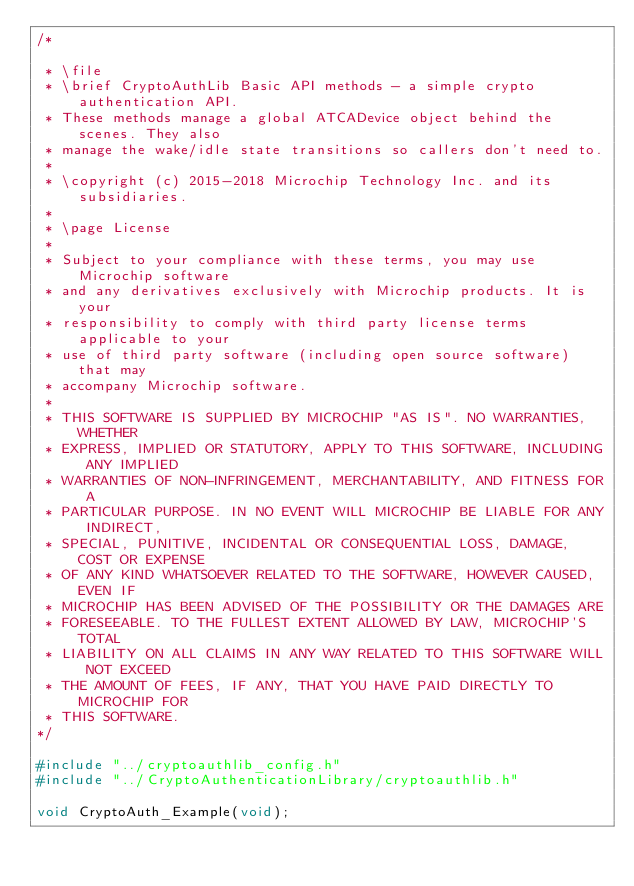<code> <loc_0><loc_0><loc_500><loc_500><_C_>/*

 * \file
 * \brief CryptoAuthLib Basic API methods - a simple crypto authentication API.
 * These methods manage a global ATCADevice object behind the scenes. They also
 * manage the wake/idle state transitions so callers don't need to.
 *
 * \copyright (c) 2015-2018 Microchip Technology Inc. and its subsidiaries.
 *
 * \page License
 *
 * Subject to your compliance with these terms, you may use Microchip software
 * and any derivatives exclusively with Microchip products. It is your
 * responsibility to comply with third party license terms applicable to your
 * use of third party software (including open source software) that may
 * accompany Microchip software.
 *
 * THIS SOFTWARE IS SUPPLIED BY MICROCHIP "AS IS". NO WARRANTIES, WHETHER
 * EXPRESS, IMPLIED OR STATUTORY, APPLY TO THIS SOFTWARE, INCLUDING ANY IMPLIED
 * WARRANTIES OF NON-INFRINGEMENT, MERCHANTABILITY, AND FITNESS FOR A
 * PARTICULAR PURPOSE. IN NO EVENT WILL MICROCHIP BE LIABLE FOR ANY INDIRECT,
 * SPECIAL, PUNITIVE, INCIDENTAL OR CONSEQUENTIAL LOSS, DAMAGE, COST OR EXPENSE
 * OF ANY KIND WHATSOEVER RELATED TO THE SOFTWARE, HOWEVER CAUSED, EVEN IF
 * MICROCHIP HAS BEEN ADVISED OF THE POSSIBILITY OR THE DAMAGES ARE
 * FORESEEABLE. TO THE FULLEST EXTENT ALLOWED BY LAW, MICROCHIP'S TOTAL
 * LIABILITY ON ALL CLAIMS IN ANY WAY RELATED TO THIS SOFTWARE WILL NOT EXCEED
 * THE AMOUNT OF FEES, IF ANY, THAT YOU HAVE PAID DIRECTLY TO MICROCHIP FOR
 * THIS SOFTWARE.
*/

#include "../cryptoauthlib_config.h"
#include "../CryptoAuthenticationLibrary/cryptoauthlib.h"

void CryptoAuth_Example(void);
</code> 